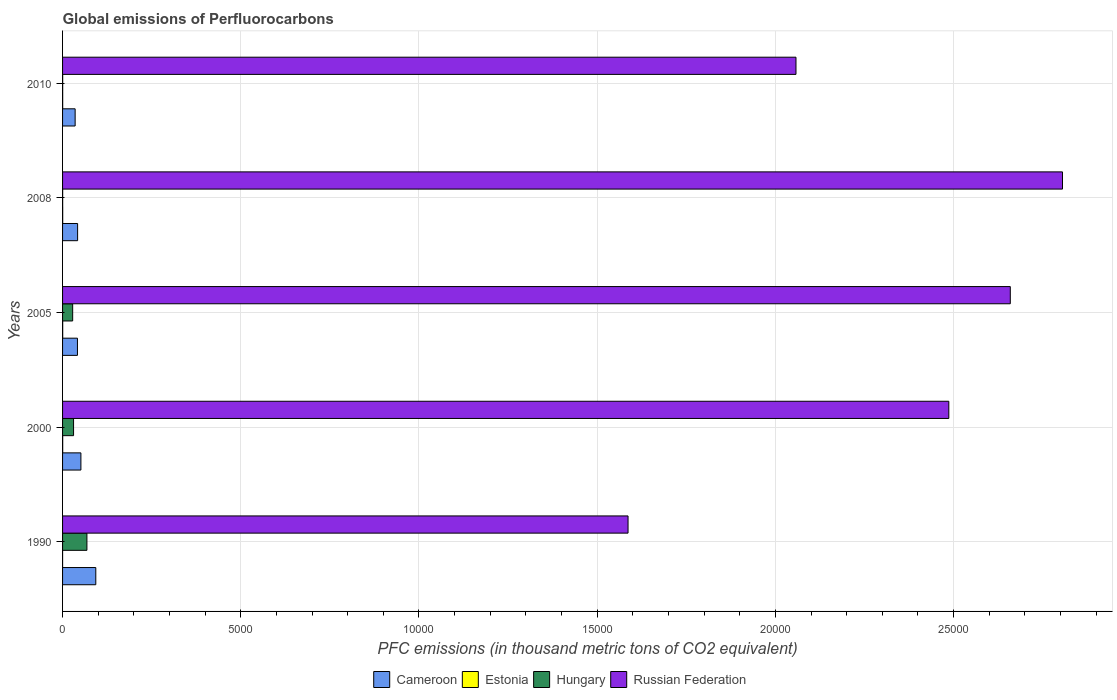How many bars are there on the 5th tick from the top?
Provide a succinct answer. 4. How many bars are there on the 4th tick from the bottom?
Offer a very short reply. 4. What is the label of the 1st group of bars from the top?
Your response must be concise. 2010. What is the global emissions of Perfluorocarbons in Russian Federation in 2010?
Offer a terse response. 2.06e+04. Across all years, what is the maximum global emissions of Perfluorocarbons in Russian Federation?
Offer a terse response. 2.81e+04. Across all years, what is the minimum global emissions of Perfluorocarbons in Russian Federation?
Give a very brief answer. 1.59e+04. In which year was the global emissions of Perfluorocarbons in Estonia maximum?
Provide a short and direct response. 2000. What is the total global emissions of Perfluorocarbons in Russian Federation in the graph?
Make the answer very short. 1.16e+05. What is the difference between the global emissions of Perfluorocarbons in Estonia in 2008 and that in 2010?
Provide a succinct answer. 0.4. What is the difference between the global emissions of Perfluorocarbons in Cameroon in 2010 and the global emissions of Perfluorocarbons in Hungary in 2000?
Provide a succinct answer. 44.5. What is the average global emissions of Perfluorocarbons in Russian Federation per year?
Provide a short and direct response. 2.32e+04. In the year 2000, what is the difference between the global emissions of Perfluorocarbons in Russian Federation and global emissions of Perfluorocarbons in Cameroon?
Your answer should be very brief. 2.44e+04. What is the ratio of the global emissions of Perfluorocarbons in Hungary in 2000 to that in 2005?
Ensure brevity in your answer.  1.09. Is the difference between the global emissions of Perfluorocarbons in Russian Federation in 1990 and 2000 greater than the difference between the global emissions of Perfluorocarbons in Cameroon in 1990 and 2000?
Provide a short and direct response. No. What is the difference between the highest and the second highest global emissions of Perfluorocarbons in Cameroon?
Your answer should be compact. 417.6. What is the difference between the highest and the lowest global emissions of Perfluorocarbons in Estonia?
Give a very brief answer. 3. Is the sum of the global emissions of Perfluorocarbons in Cameroon in 2000 and 2008 greater than the maximum global emissions of Perfluorocarbons in Estonia across all years?
Keep it short and to the point. Yes. Is it the case that in every year, the sum of the global emissions of Perfluorocarbons in Hungary and global emissions of Perfluorocarbons in Cameroon is greater than the sum of global emissions of Perfluorocarbons in Estonia and global emissions of Perfluorocarbons in Russian Federation?
Give a very brief answer. No. What does the 3rd bar from the top in 2010 represents?
Keep it short and to the point. Estonia. What does the 4th bar from the bottom in 2005 represents?
Give a very brief answer. Russian Federation. Are all the bars in the graph horizontal?
Make the answer very short. Yes. What is the title of the graph?
Your answer should be compact. Global emissions of Perfluorocarbons. Does "Albania" appear as one of the legend labels in the graph?
Ensure brevity in your answer.  No. What is the label or title of the X-axis?
Offer a terse response. PFC emissions (in thousand metric tons of CO2 equivalent). What is the label or title of the Y-axis?
Offer a very short reply. Years. What is the PFC emissions (in thousand metric tons of CO2 equivalent) of Cameroon in 1990?
Provide a short and direct response. 932.3. What is the PFC emissions (in thousand metric tons of CO2 equivalent) in Estonia in 1990?
Your response must be concise. 0.5. What is the PFC emissions (in thousand metric tons of CO2 equivalent) in Hungary in 1990?
Offer a very short reply. 683.3. What is the PFC emissions (in thousand metric tons of CO2 equivalent) in Russian Federation in 1990?
Provide a short and direct response. 1.59e+04. What is the PFC emissions (in thousand metric tons of CO2 equivalent) in Cameroon in 2000?
Provide a succinct answer. 514.7. What is the PFC emissions (in thousand metric tons of CO2 equivalent) in Hungary in 2000?
Give a very brief answer. 308.5. What is the PFC emissions (in thousand metric tons of CO2 equivalent) of Russian Federation in 2000?
Keep it short and to the point. 2.49e+04. What is the PFC emissions (in thousand metric tons of CO2 equivalent) in Cameroon in 2005?
Keep it short and to the point. 417.5. What is the PFC emissions (in thousand metric tons of CO2 equivalent) of Estonia in 2005?
Your answer should be compact. 3.4. What is the PFC emissions (in thousand metric tons of CO2 equivalent) of Hungary in 2005?
Provide a short and direct response. 283.7. What is the PFC emissions (in thousand metric tons of CO2 equivalent) in Russian Federation in 2005?
Your answer should be compact. 2.66e+04. What is the PFC emissions (in thousand metric tons of CO2 equivalent) in Cameroon in 2008?
Make the answer very short. 422.1. What is the PFC emissions (in thousand metric tons of CO2 equivalent) of Estonia in 2008?
Offer a very short reply. 3.4. What is the PFC emissions (in thousand metric tons of CO2 equivalent) in Russian Federation in 2008?
Give a very brief answer. 2.81e+04. What is the PFC emissions (in thousand metric tons of CO2 equivalent) in Cameroon in 2010?
Make the answer very short. 353. What is the PFC emissions (in thousand metric tons of CO2 equivalent) of Hungary in 2010?
Give a very brief answer. 3. What is the PFC emissions (in thousand metric tons of CO2 equivalent) of Russian Federation in 2010?
Ensure brevity in your answer.  2.06e+04. Across all years, what is the maximum PFC emissions (in thousand metric tons of CO2 equivalent) of Cameroon?
Ensure brevity in your answer.  932.3. Across all years, what is the maximum PFC emissions (in thousand metric tons of CO2 equivalent) of Hungary?
Your answer should be compact. 683.3. Across all years, what is the maximum PFC emissions (in thousand metric tons of CO2 equivalent) of Russian Federation?
Make the answer very short. 2.81e+04. Across all years, what is the minimum PFC emissions (in thousand metric tons of CO2 equivalent) of Cameroon?
Keep it short and to the point. 353. Across all years, what is the minimum PFC emissions (in thousand metric tons of CO2 equivalent) in Estonia?
Ensure brevity in your answer.  0.5. Across all years, what is the minimum PFC emissions (in thousand metric tons of CO2 equivalent) in Russian Federation?
Your answer should be compact. 1.59e+04. What is the total PFC emissions (in thousand metric tons of CO2 equivalent) in Cameroon in the graph?
Make the answer very short. 2639.6. What is the total PFC emissions (in thousand metric tons of CO2 equivalent) of Hungary in the graph?
Your response must be concise. 1281.2. What is the total PFC emissions (in thousand metric tons of CO2 equivalent) in Russian Federation in the graph?
Ensure brevity in your answer.  1.16e+05. What is the difference between the PFC emissions (in thousand metric tons of CO2 equivalent) of Cameroon in 1990 and that in 2000?
Offer a very short reply. 417.6. What is the difference between the PFC emissions (in thousand metric tons of CO2 equivalent) of Hungary in 1990 and that in 2000?
Your answer should be very brief. 374.8. What is the difference between the PFC emissions (in thousand metric tons of CO2 equivalent) in Russian Federation in 1990 and that in 2000?
Your answer should be very brief. -8999.9. What is the difference between the PFC emissions (in thousand metric tons of CO2 equivalent) of Cameroon in 1990 and that in 2005?
Give a very brief answer. 514.8. What is the difference between the PFC emissions (in thousand metric tons of CO2 equivalent) of Estonia in 1990 and that in 2005?
Ensure brevity in your answer.  -2.9. What is the difference between the PFC emissions (in thousand metric tons of CO2 equivalent) in Hungary in 1990 and that in 2005?
Give a very brief answer. 399.6. What is the difference between the PFC emissions (in thousand metric tons of CO2 equivalent) in Russian Federation in 1990 and that in 2005?
Ensure brevity in your answer.  -1.07e+04. What is the difference between the PFC emissions (in thousand metric tons of CO2 equivalent) in Cameroon in 1990 and that in 2008?
Ensure brevity in your answer.  510.2. What is the difference between the PFC emissions (in thousand metric tons of CO2 equivalent) in Hungary in 1990 and that in 2008?
Your answer should be very brief. 680.6. What is the difference between the PFC emissions (in thousand metric tons of CO2 equivalent) in Russian Federation in 1990 and that in 2008?
Ensure brevity in your answer.  -1.22e+04. What is the difference between the PFC emissions (in thousand metric tons of CO2 equivalent) in Cameroon in 1990 and that in 2010?
Offer a terse response. 579.3. What is the difference between the PFC emissions (in thousand metric tons of CO2 equivalent) in Hungary in 1990 and that in 2010?
Your response must be concise. 680.3. What is the difference between the PFC emissions (in thousand metric tons of CO2 equivalent) of Russian Federation in 1990 and that in 2010?
Provide a succinct answer. -4711.8. What is the difference between the PFC emissions (in thousand metric tons of CO2 equivalent) in Cameroon in 2000 and that in 2005?
Keep it short and to the point. 97.2. What is the difference between the PFC emissions (in thousand metric tons of CO2 equivalent) of Hungary in 2000 and that in 2005?
Your answer should be very brief. 24.8. What is the difference between the PFC emissions (in thousand metric tons of CO2 equivalent) of Russian Federation in 2000 and that in 2005?
Give a very brief answer. -1725.2. What is the difference between the PFC emissions (in thousand metric tons of CO2 equivalent) in Cameroon in 2000 and that in 2008?
Offer a very short reply. 92.6. What is the difference between the PFC emissions (in thousand metric tons of CO2 equivalent) of Estonia in 2000 and that in 2008?
Provide a succinct answer. 0.1. What is the difference between the PFC emissions (in thousand metric tons of CO2 equivalent) of Hungary in 2000 and that in 2008?
Keep it short and to the point. 305.8. What is the difference between the PFC emissions (in thousand metric tons of CO2 equivalent) of Russian Federation in 2000 and that in 2008?
Give a very brief answer. -3189.7. What is the difference between the PFC emissions (in thousand metric tons of CO2 equivalent) in Cameroon in 2000 and that in 2010?
Offer a terse response. 161.7. What is the difference between the PFC emissions (in thousand metric tons of CO2 equivalent) in Estonia in 2000 and that in 2010?
Keep it short and to the point. 0.5. What is the difference between the PFC emissions (in thousand metric tons of CO2 equivalent) in Hungary in 2000 and that in 2010?
Keep it short and to the point. 305.5. What is the difference between the PFC emissions (in thousand metric tons of CO2 equivalent) in Russian Federation in 2000 and that in 2010?
Your answer should be compact. 4288.1. What is the difference between the PFC emissions (in thousand metric tons of CO2 equivalent) of Estonia in 2005 and that in 2008?
Provide a succinct answer. 0. What is the difference between the PFC emissions (in thousand metric tons of CO2 equivalent) of Hungary in 2005 and that in 2008?
Provide a succinct answer. 281. What is the difference between the PFC emissions (in thousand metric tons of CO2 equivalent) of Russian Federation in 2005 and that in 2008?
Ensure brevity in your answer.  -1464.5. What is the difference between the PFC emissions (in thousand metric tons of CO2 equivalent) of Cameroon in 2005 and that in 2010?
Give a very brief answer. 64.5. What is the difference between the PFC emissions (in thousand metric tons of CO2 equivalent) of Estonia in 2005 and that in 2010?
Your answer should be compact. 0.4. What is the difference between the PFC emissions (in thousand metric tons of CO2 equivalent) in Hungary in 2005 and that in 2010?
Keep it short and to the point. 280.7. What is the difference between the PFC emissions (in thousand metric tons of CO2 equivalent) of Russian Federation in 2005 and that in 2010?
Provide a short and direct response. 6013.3. What is the difference between the PFC emissions (in thousand metric tons of CO2 equivalent) of Cameroon in 2008 and that in 2010?
Your response must be concise. 69.1. What is the difference between the PFC emissions (in thousand metric tons of CO2 equivalent) in Estonia in 2008 and that in 2010?
Your answer should be very brief. 0.4. What is the difference between the PFC emissions (in thousand metric tons of CO2 equivalent) in Russian Federation in 2008 and that in 2010?
Your answer should be very brief. 7477.8. What is the difference between the PFC emissions (in thousand metric tons of CO2 equivalent) in Cameroon in 1990 and the PFC emissions (in thousand metric tons of CO2 equivalent) in Estonia in 2000?
Offer a terse response. 928.8. What is the difference between the PFC emissions (in thousand metric tons of CO2 equivalent) in Cameroon in 1990 and the PFC emissions (in thousand metric tons of CO2 equivalent) in Hungary in 2000?
Make the answer very short. 623.8. What is the difference between the PFC emissions (in thousand metric tons of CO2 equivalent) of Cameroon in 1990 and the PFC emissions (in thousand metric tons of CO2 equivalent) of Russian Federation in 2000?
Your answer should be very brief. -2.39e+04. What is the difference between the PFC emissions (in thousand metric tons of CO2 equivalent) of Estonia in 1990 and the PFC emissions (in thousand metric tons of CO2 equivalent) of Hungary in 2000?
Provide a short and direct response. -308. What is the difference between the PFC emissions (in thousand metric tons of CO2 equivalent) in Estonia in 1990 and the PFC emissions (in thousand metric tons of CO2 equivalent) in Russian Federation in 2000?
Provide a short and direct response. -2.49e+04. What is the difference between the PFC emissions (in thousand metric tons of CO2 equivalent) of Hungary in 1990 and the PFC emissions (in thousand metric tons of CO2 equivalent) of Russian Federation in 2000?
Your answer should be compact. -2.42e+04. What is the difference between the PFC emissions (in thousand metric tons of CO2 equivalent) in Cameroon in 1990 and the PFC emissions (in thousand metric tons of CO2 equivalent) in Estonia in 2005?
Make the answer very short. 928.9. What is the difference between the PFC emissions (in thousand metric tons of CO2 equivalent) in Cameroon in 1990 and the PFC emissions (in thousand metric tons of CO2 equivalent) in Hungary in 2005?
Keep it short and to the point. 648.6. What is the difference between the PFC emissions (in thousand metric tons of CO2 equivalent) in Cameroon in 1990 and the PFC emissions (in thousand metric tons of CO2 equivalent) in Russian Federation in 2005?
Make the answer very short. -2.57e+04. What is the difference between the PFC emissions (in thousand metric tons of CO2 equivalent) of Estonia in 1990 and the PFC emissions (in thousand metric tons of CO2 equivalent) of Hungary in 2005?
Provide a short and direct response. -283.2. What is the difference between the PFC emissions (in thousand metric tons of CO2 equivalent) in Estonia in 1990 and the PFC emissions (in thousand metric tons of CO2 equivalent) in Russian Federation in 2005?
Ensure brevity in your answer.  -2.66e+04. What is the difference between the PFC emissions (in thousand metric tons of CO2 equivalent) of Hungary in 1990 and the PFC emissions (in thousand metric tons of CO2 equivalent) of Russian Federation in 2005?
Provide a short and direct response. -2.59e+04. What is the difference between the PFC emissions (in thousand metric tons of CO2 equivalent) in Cameroon in 1990 and the PFC emissions (in thousand metric tons of CO2 equivalent) in Estonia in 2008?
Ensure brevity in your answer.  928.9. What is the difference between the PFC emissions (in thousand metric tons of CO2 equivalent) in Cameroon in 1990 and the PFC emissions (in thousand metric tons of CO2 equivalent) in Hungary in 2008?
Ensure brevity in your answer.  929.6. What is the difference between the PFC emissions (in thousand metric tons of CO2 equivalent) in Cameroon in 1990 and the PFC emissions (in thousand metric tons of CO2 equivalent) in Russian Federation in 2008?
Your answer should be compact. -2.71e+04. What is the difference between the PFC emissions (in thousand metric tons of CO2 equivalent) of Estonia in 1990 and the PFC emissions (in thousand metric tons of CO2 equivalent) of Russian Federation in 2008?
Your answer should be very brief. -2.81e+04. What is the difference between the PFC emissions (in thousand metric tons of CO2 equivalent) of Hungary in 1990 and the PFC emissions (in thousand metric tons of CO2 equivalent) of Russian Federation in 2008?
Give a very brief answer. -2.74e+04. What is the difference between the PFC emissions (in thousand metric tons of CO2 equivalent) of Cameroon in 1990 and the PFC emissions (in thousand metric tons of CO2 equivalent) of Estonia in 2010?
Keep it short and to the point. 929.3. What is the difference between the PFC emissions (in thousand metric tons of CO2 equivalent) of Cameroon in 1990 and the PFC emissions (in thousand metric tons of CO2 equivalent) of Hungary in 2010?
Give a very brief answer. 929.3. What is the difference between the PFC emissions (in thousand metric tons of CO2 equivalent) in Cameroon in 1990 and the PFC emissions (in thousand metric tons of CO2 equivalent) in Russian Federation in 2010?
Your answer should be very brief. -1.96e+04. What is the difference between the PFC emissions (in thousand metric tons of CO2 equivalent) in Estonia in 1990 and the PFC emissions (in thousand metric tons of CO2 equivalent) in Hungary in 2010?
Make the answer very short. -2.5. What is the difference between the PFC emissions (in thousand metric tons of CO2 equivalent) in Estonia in 1990 and the PFC emissions (in thousand metric tons of CO2 equivalent) in Russian Federation in 2010?
Offer a terse response. -2.06e+04. What is the difference between the PFC emissions (in thousand metric tons of CO2 equivalent) in Hungary in 1990 and the PFC emissions (in thousand metric tons of CO2 equivalent) in Russian Federation in 2010?
Make the answer very short. -1.99e+04. What is the difference between the PFC emissions (in thousand metric tons of CO2 equivalent) in Cameroon in 2000 and the PFC emissions (in thousand metric tons of CO2 equivalent) in Estonia in 2005?
Your answer should be compact. 511.3. What is the difference between the PFC emissions (in thousand metric tons of CO2 equivalent) of Cameroon in 2000 and the PFC emissions (in thousand metric tons of CO2 equivalent) of Hungary in 2005?
Offer a terse response. 231. What is the difference between the PFC emissions (in thousand metric tons of CO2 equivalent) in Cameroon in 2000 and the PFC emissions (in thousand metric tons of CO2 equivalent) in Russian Federation in 2005?
Offer a terse response. -2.61e+04. What is the difference between the PFC emissions (in thousand metric tons of CO2 equivalent) in Estonia in 2000 and the PFC emissions (in thousand metric tons of CO2 equivalent) in Hungary in 2005?
Provide a succinct answer. -280.2. What is the difference between the PFC emissions (in thousand metric tons of CO2 equivalent) of Estonia in 2000 and the PFC emissions (in thousand metric tons of CO2 equivalent) of Russian Federation in 2005?
Make the answer very short. -2.66e+04. What is the difference between the PFC emissions (in thousand metric tons of CO2 equivalent) of Hungary in 2000 and the PFC emissions (in thousand metric tons of CO2 equivalent) of Russian Federation in 2005?
Offer a terse response. -2.63e+04. What is the difference between the PFC emissions (in thousand metric tons of CO2 equivalent) in Cameroon in 2000 and the PFC emissions (in thousand metric tons of CO2 equivalent) in Estonia in 2008?
Make the answer very short. 511.3. What is the difference between the PFC emissions (in thousand metric tons of CO2 equivalent) of Cameroon in 2000 and the PFC emissions (in thousand metric tons of CO2 equivalent) of Hungary in 2008?
Your response must be concise. 512. What is the difference between the PFC emissions (in thousand metric tons of CO2 equivalent) in Cameroon in 2000 and the PFC emissions (in thousand metric tons of CO2 equivalent) in Russian Federation in 2008?
Provide a succinct answer. -2.75e+04. What is the difference between the PFC emissions (in thousand metric tons of CO2 equivalent) of Estonia in 2000 and the PFC emissions (in thousand metric tons of CO2 equivalent) of Hungary in 2008?
Offer a terse response. 0.8. What is the difference between the PFC emissions (in thousand metric tons of CO2 equivalent) in Estonia in 2000 and the PFC emissions (in thousand metric tons of CO2 equivalent) in Russian Federation in 2008?
Your answer should be compact. -2.81e+04. What is the difference between the PFC emissions (in thousand metric tons of CO2 equivalent) of Hungary in 2000 and the PFC emissions (in thousand metric tons of CO2 equivalent) of Russian Federation in 2008?
Your response must be concise. -2.77e+04. What is the difference between the PFC emissions (in thousand metric tons of CO2 equivalent) of Cameroon in 2000 and the PFC emissions (in thousand metric tons of CO2 equivalent) of Estonia in 2010?
Provide a succinct answer. 511.7. What is the difference between the PFC emissions (in thousand metric tons of CO2 equivalent) of Cameroon in 2000 and the PFC emissions (in thousand metric tons of CO2 equivalent) of Hungary in 2010?
Give a very brief answer. 511.7. What is the difference between the PFC emissions (in thousand metric tons of CO2 equivalent) in Cameroon in 2000 and the PFC emissions (in thousand metric tons of CO2 equivalent) in Russian Federation in 2010?
Your response must be concise. -2.01e+04. What is the difference between the PFC emissions (in thousand metric tons of CO2 equivalent) in Estonia in 2000 and the PFC emissions (in thousand metric tons of CO2 equivalent) in Russian Federation in 2010?
Your response must be concise. -2.06e+04. What is the difference between the PFC emissions (in thousand metric tons of CO2 equivalent) of Hungary in 2000 and the PFC emissions (in thousand metric tons of CO2 equivalent) of Russian Federation in 2010?
Your answer should be very brief. -2.03e+04. What is the difference between the PFC emissions (in thousand metric tons of CO2 equivalent) in Cameroon in 2005 and the PFC emissions (in thousand metric tons of CO2 equivalent) in Estonia in 2008?
Your response must be concise. 414.1. What is the difference between the PFC emissions (in thousand metric tons of CO2 equivalent) in Cameroon in 2005 and the PFC emissions (in thousand metric tons of CO2 equivalent) in Hungary in 2008?
Ensure brevity in your answer.  414.8. What is the difference between the PFC emissions (in thousand metric tons of CO2 equivalent) in Cameroon in 2005 and the PFC emissions (in thousand metric tons of CO2 equivalent) in Russian Federation in 2008?
Your response must be concise. -2.76e+04. What is the difference between the PFC emissions (in thousand metric tons of CO2 equivalent) in Estonia in 2005 and the PFC emissions (in thousand metric tons of CO2 equivalent) in Hungary in 2008?
Provide a short and direct response. 0.7. What is the difference between the PFC emissions (in thousand metric tons of CO2 equivalent) in Estonia in 2005 and the PFC emissions (in thousand metric tons of CO2 equivalent) in Russian Federation in 2008?
Your answer should be compact. -2.81e+04. What is the difference between the PFC emissions (in thousand metric tons of CO2 equivalent) of Hungary in 2005 and the PFC emissions (in thousand metric tons of CO2 equivalent) of Russian Federation in 2008?
Provide a succinct answer. -2.78e+04. What is the difference between the PFC emissions (in thousand metric tons of CO2 equivalent) in Cameroon in 2005 and the PFC emissions (in thousand metric tons of CO2 equivalent) in Estonia in 2010?
Keep it short and to the point. 414.5. What is the difference between the PFC emissions (in thousand metric tons of CO2 equivalent) of Cameroon in 2005 and the PFC emissions (in thousand metric tons of CO2 equivalent) of Hungary in 2010?
Your response must be concise. 414.5. What is the difference between the PFC emissions (in thousand metric tons of CO2 equivalent) in Cameroon in 2005 and the PFC emissions (in thousand metric tons of CO2 equivalent) in Russian Federation in 2010?
Your response must be concise. -2.02e+04. What is the difference between the PFC emissions (in thousand metric tons of CO2 equivalent) of Estonia in 2005 and the PFC emissions (in thousand metric tons of CO2 equivalent) of Russian Federation in 2010?
Offer a very short reply. -2.06e+04. What is the difference between the PFC emissions (in thousand metric tons of CO2 equivalent) of Hungary in 2005 and the PFC emissions (in thousand metric tons of CO2 equivalent) of Russian Federation in 2010?
Your answer should be compact. -2.03e+04. What is the difference between the PFC emissions (in thousand metric tons of CO2 equivalent) in Cameroon in 2008 and the PFC emissions (in thousand metric tons of CO2 equivalent) in Estonia in 2010?
Offer a very short reply. 419.1. What is the difference between the PFC emissions (in thousand metric tons of CO2 equivalent) in Cameroon in 2008 and the PFC emissions (in thousand metric tons of CO2 equivalent) in Hungary in 2010?
Offer a very short reply. 419.1. What is the difference between the PFC emissions (in thousand metric tons of CO2 equivalent) in Cameroon in 2008 and the PFC emissions (in thousand metric tons of CO2 equivalent) in Russian Federation in 2010?
Your response must be concise. -2.02e+04. What is the difference between the PFC emissions (in thousand metric tons of CO2 equivalent) in Estonia in 2008 and the PFC emissions (in thousand metric tons of CO2 equivalent) in Russian Federation in 2010?
Give a very brief answer. -2.06e+04. What is the difference between the PFC emissions (in thousand metric tons of CO2 equivalent) of Hungary in 2008 and the PFC emissions (in thousand metric tons of CO2 equivalent) of Russian Federation in 2010?
Offer a very short reply. -2.06e+04. What is the average PFC emissions (in thousand metric tons of CO2 equivalent) in Cameroon per year?
Provide a succinct answer. 527.92. What is the average PFC emissions (in thousand metric tons of CO2 equivalent) in Estonia per year?
Give a very brief answer. 2.76. What is the average PFC emissions (in thousand metric tons of CO2 equivalent) in Hungary per year?
Ensure brevity in your answer.  256.24. What is the average PFC emissions (in thousand metric tons of CO2 equivalent) in Russian Federation per year?
Your response must be concise. 2.32e+04. In the year 1990, what is the difference between the PFC emissions (in thousand metric tons of CO2 equivalent) of Cameroon and PFC emissions (in thousand metric tons of CO2 equivalent) of Estonia?
Your answer should be compact. 931.8. In the year 1990, what is the difference between the PFC emissions (in thousand metric tons of CO2 equivalent) in Cameroon and PFC emissions (in thousand metric tons of CO2 equivalent) in Hungary?
Give a very brief answer. 249. In the year 1990, what is the difference between the PFC emissions (in thousand metric tons of CO2 equivalent) in Cameroon and PFC emissions (in thousand metric tons of CO2 equivalent) in Russian Federation?
Give a very brief answer. -1.49e+04. In the year 1990, what is the difference between the PFC emissions (in thousand metric tons of CO2 equivalent) in Estonia and PFC emissions (in thousand metric tons of CO2 equivalent) in Hungary?
Your answer should be very brief. -682.8. In the year 1990, what is the difference between the PFC emissions (in thousand metric tons of CO2 equivalent) of Estonia and PFC emissions (in thousand metric tons of CO2 equivalent) of Russian Federation?
Provide a short and direct response. -1.59e+04. In the year 1990, what is the difference between the PFC emissions (in thousand metric tons of CO2 equivalent) in Hungary and PFC emissions (in thousand metric tons of CO2 equivalent) in Russian Federation?
Provide a succinct answer. -1.52e+04. In the year 2000, what is the difference between the PFC emissions (in thousand metric tons of CO2 equivalent) of Cameroon and PFC emissions (in thousand metric tons of CO2 equivalent) of Estonia?
Ensure brevity in your answer.  511.2. In the year 2000, what is the difference between the PFC emissions (in thousand metric tons of CO2 equivalent) of Cameroon and PFC emissions (in thousand metric tons of CO2 equivalent) of Hungary?
Give a very brief answer. 206.2. In the year 2000, what is the difference between the PFC emissions (in thousand metric tons of CO2 equivalent) in Cameroon and PFC emissions (in thousand metric tons of CO2 equivalent) in Russian Federation?
Your answer should be compact. -2.44e+04. In the year 2000, what is the difference between the PFC emissions (in thousand metric tons of CO2 equivalent) in Estonia and PFC emissions (in thousand metric tons of CO2 equivalent) in Hungary?
Your answer should be compact. -305. In the year 2000, what is the difference between the PFC emissions (in thousand metric tons of CO2 equivalent) of Estonia and PFC emissions (in thousand metric tons of CO2 equivalent) of Russian Federation?
Your response must be concise. -2.49e+04. In the year 2000, what is the difference between the PFC emissions (in thousand metric tons of CO2 equivalent) in Hungary and PFC emissions (in thousand metric tons of CO2 equivalent) in Russian Federation?
Provide a short and direct response. -2.46e+04. In the year 2005, what is the difference between the PFC emissions (in thousand metric tons of CO2 equivalent) of Cameroon and PFC emissions (in thousand metric tons of CO2 equivalent) of Estonia?
Ensure brevity in your answer.  414.1. In the year 2005, what is the difference between the PFC emissions (in thousand metric tons of CO2 equivalent) in Cameroon and PFC emissions (in thousand metric tons of CO2 equivalent) in Hungary?
Give a very brief answer. 133.8. In the year 2005, what is the difference between the PFC emissions (in thousand metric tons of CO2 equivalent) of Cameroon and PFC emissions (in thousand metric tons of CO2 equivalent) of Russian Federation?
Provide a succinct answer. -2.62e+04. In the year 2005, what is the difference between the PFC emissions (in thousand metric tons of CO2 equivalent) in Estonia and PFC emissions (in thousand metric tons of CO2 equivalent) in Hungary?
Offer a very short reply. -280.3. In the year 2005, what is the difference between the PFC emissions (in thousand metric tons of CO2 equivalent) of Estonia and PFC emissions (in thousand metric tons of CO2 equivalent) of Russian Federation?
Keep it short and to the point. -2.66e+04. In the year 2005, what is the difference between the PFC emissions (in thousand metric tons of CO2 equivalent) of Hungary and PFC emissions (in thousand metric tons of CO2 equivalent) of Russian Federation?
Offer a terse response. -2.63e+04. In the year 2008, what is the difference between the PFC emissions (in thousand metric tons of CO2 equivalent) of Cameroon and PFC emissions (in thousand metric tons of CO2 equivalent) of Estonia?
Your response must be concise. 418.7. In the year 2008, what is the difference between the PFC emissions (in thousand metric tons of CO2 equivalent) of Cameroon and PFC emissions (in thousand metric tons of CO2 equivalent) of Hungary?
Ensure brevity in your answer.  419.4. In the year 2008, what is the difference between the PFC emissions (in thousand metric tons of CO2 equivalent) in Cameroon and PFC emissions (in thousand metric tons of CO2 equivalent) in Russian Federation?
Your answer should be compact. -2.76e+04. In the year 2008, what is the difference between the PFC emissions (in thousand metric tons of CO2 equivalent) in Estonia and PFC emissions (in thousand metric tons of CO2 equivalent) in Hungary?
Offer a terse response. 0.7. In the year 2008, what is the difference between the PFC emissions (in thousand metric tons of CO2 equivalent) in Estonia and PFC emissions (in thousand metric tons of CO2 equivalent) in Russian Federation?
Your answer should be very brief. -2.81e+04. In the year 2008, what is the difference between the PFC emissions (in thousand metric tons of CO2 equivalent) in Hungary and PFC emissions (in thousand metric tons of CO2 equivalent) in Russian Federation?
Your answer should be compact. -2.81e+04. In the year 2010, what is the difference between the PFC emissions (in thousand metric tons of CO2 equivalent) of Cameroon and PFC emissions (in thousand metric tons of CO2 equivalent) of Estonia?
Your response must be concise. 350. In the year 2010, what is the difference between the PFC emissions (in thousand metric tons of CO2 equivalent) in Cameroon and PFC emissions (in thousand metric tons of CO2 equivalent) in Hungary?
Make the answer very short. 350. In the year 2010, what is the difference between the PFC emissions (in thousand metric tons of CO2 equivalent) in Cameroon and PFC emissions (in thousand metric tons of CO2 equivalent) in Russian Federation?
Make the answer very short. -2.02e+04. In the year 2010, what is the difference between the PFC emissions (in thousand metric tons of CO2 equivalent) of Estonia and PFC emissions (in thousand metric tons of CO2 equivalent) of Russian Federation?
Ensure brevity in your answer.  -2.06e+04. In the year 2010, what is the difference between the PFC emissions (in thousand metric tons of CO2 equivalent) in Hungary and PFC emissions (in thousand metric tons of CO2 equivalent) in Russian Federation?
Make the answer very short. -2.06e+04. What is the ratio of the PFC emissions (in thousand metric tons of CO2 equivalent) of Cameroon in 1990 to that in 2000?
Provide a short and direct response. 1.81. What is the ratio of the PFC emissions (in thousand metric tons of CO2 equivalent) of Estonia in 1990 to that in 2000?
Your answer should be very brief. 0.14. What is the ratio of the PFC emissions (in thousand metric tons of CO2 equivalent) of Hungary in 1990 to that in 2000?
Your answer should be very brief. 2.21. What is the ratio of the PFC emissions (in thousand metric tons of CO2 equivalent) in Russian Federation in 1990 to that in 2000?
Provide a succinct answer. 0.64. What is the ratio of the PFC emissions (in thousand metric tons of CO2 equivalent) in Cameroon in 1990 to that in 2005?
Your answer should be compact. 2.23. What is the ratio of the PFC emissions (in thousand metric tons of CO2 equivalent) of Estonia in 1990 to that in 2005?
Offer a terse response. 0.15. What is the ratio of the PFC emissions (in thousand metric tons of CO2 equivalent) in Hungary in 1990 to that in 2005?
Keep it short and to the point. 2.41. What is the ratio of the PFC emissions (in thousand metric tons of CO2 equivalent) in Russian Federation in 1990 to that in 2005?
Your answer should be compact. 0.6. What is the ratio of the PFC emissions (in thousand metric tons of CO2 equivalent) of Cameroon in 1990 to that in 2008?
Your answer should be compact. 2.21. What is the ratio of the PFC emissions (in thousand metric tons of CO2 equivalent) of Estonia in 1990 to that in 2008?
Ensure brevity in your answer.  0.15. What is the ratio of the PFC emissions (in thousand metric tons of CO2 equivalent) of Hungary in 1990 to that in 2008?
Your response must be concise. 253.07. What is the ratio of the PFC emissions (in thousand metric tons of CO2 equivalent) in Russian Federation in 1990 to that in 2008?
Offer a terse response. 0.57. What is the ratio of the PFC emissions (in thousand metric tons of CO2 equivalent) of Cameroon in 1990 to that in 2010?
Your answer should be very brief. 2.64. What is the ratio of the PFC emissions (in thousand metric tons of CO2 equivalent) in Estonia in 1990 to that in 2010?
Your answer should be very brief. 0.17. What is the ratio of the PFC emissions (in thousand metric tons of CO2 equivalent) of Hungary in 1990 to that in 2010?
Offer a terse response. 227.77. What is the ratio of the PFC emissions (in thousand metric tons of CO2 equivalent) of Russian Federation in 1990 to that in 2010?
Keep it short and to the point. 0.77. What is the ratio of the PFC emissions (in thousand metric tons of CO2 equivalent) of Cameroon in 2000 to that in 2005?
Provide a short and direct response. 1.23. What is the ratio of the PFC emissions (in thousand metric tons of CO2 equivalent) in Estonia in 2000 to that in 2005?
Give a very brief answer. 1.03. What is the ratio of the PFC emissions (in thousand metric tons of CO2 equivalent) in Hungary in 2000 to that in 2005?
Make the answer very short. 1.09. What is the ratio of the PFC emissions (in thousand metric tons of CO2 equivalent) of Russian Federation in 2000 to that in 2005?
Provide a succinct answer. 0.94. What is the ratio of the PFC emissions (in thousand metric tons of CO2 equivalent) of Cameroon in 2000 to that in 2008?
Provide a short and direct response. 1.22. What is the ratio of the PFC emissions (in thousand metric tons of CO2 equivalent) of Estonia in 2000 to that in 2008?
Keep it short and to the point. 1.03. What is the ratio of the PFC emissions (in thousand metric tons of CO2 equivalent) in Hungary in 2000 to that in 2008?
Provide a short and direct response. 114.26. What is the ratio of the PFC emissions (in thousand metric tons of CO2 equivalent) in Russian Federation in 2000 to that in 2008?
Make the answer very short. 0.89. What is the ratio of the PFC emissions (in thousand metric tons of CO2 equivalent) of Cameroon in 2000 to that in 2010?
Your answer should be compact. 1.46. What is the ratio of the PFC emissions (in thousand metric tons of CO2 equivalent) of Estonia in 2000 to that in 2010?
Offer a very short reply. 1.17. What is the ratio of the PFC emissions (in thousand metric tons of CO2 equivalent) of Hungary in 2000 to that in 2010?
Give a very brief answer. 102.83. What is the ratio of the PFC emissions (in thousand metric tons of CO2 equivalent) in Russian Federation in 2000 to that in 2010?
Give a very brief answer. 1.21. What is the ratio of the PFC emissions (in thousand metric tons of CO2 equivalent) of Estonia in 2005 to that in 2008?
Offer a terse response. 1. What is the ratio of the PFC emissions (in thousand metric tons of CO2 equivalent) of Hungary in 2005 to that in 2008?
Provide a succinct answer. 105.07. What is the ratio of the PFC emissions (in thousand metric tons of CO2 equivalent) of Russian Federation in 2005 to that in 2008?
Provide a short and direct response. 0.95. What is the ratio of the PFC emissions (in thousand metric tons of CO2 equivalent) of Cameroon in 2005 to that in 2010?
Provide a succinct answer. 1.18. What is the ratio of the PFC emissions (in thousand metric tons of CO2 equivalent) in Estonia in 2005 to that in 2010?
Provide a short and direct response. 1.13. What is the ratio of the PFC emissions (in thousand metric tons of CO2 equivalent) in Hungary in 2005 to that in 2010?
Provide a short and direct response. 94.57. What is the ratio of the PFC emissions (in thousand metric tons of CO2 equivalent) in Russian Federation in 2005 to that in 2010?
Make the answer very short. 1.29. What is the ratio of the PFC emissions (in thousand metric tons of CO2 equivalent) in Cameroon in 2008 to that in 2010?
Make the answer very short. 1.2. What is the ratio of the PFC emissions (in thousand metric tons of CO2 equivalent) of Estonia in 2008 to that in 2010?
Ensure brevity in your answer.  1.13. What is the ratio of the PFC emissions (in thousand metric tons of CO2 equivalent) of Hungary in 2008 to that in 2010?
Make the answer very short. 0.9. What is the ratio of the PFC emissions (in thousand metric tons of CO2 equivalent) of Russian Federation in 2008 to that in 2010?
Provide a succinct answer. 1.36. What is the difference between the highest and the second highest PFC emissions (in thousand metric tons of CO2 equivalent) of Cameroon?
Provide a short and direct response. 417.6. What is the difference between the highest and the second highest PFC emissions (in thousand metric tons of CO2 equivalent) of Hungary?
Offer a very short reply. 374.8. What is the difference between the highest and the second highest PFC emissions (in thousand metric tons of CO2 equivalent) of Russian Federation?
Provide a succinct answer. 1464.5. What is the difference between the highest and the lowest PFC emissions (in thousand metric tons of CO2 equivalent) of Cameroon?
Keep it short and to the point. 579.3. What is the difference between the highest and the lowest PFC emissions (in thousand metric tons of CO2 equivalent) of Estonia?
Your response must be concise. 3. What is the difference between the highest and the lowest PFC emissions (in thousand metric tons of CO2 equivalent) in Hungary?
Give a very brief answer. 680.6. What is the difference between the highest and the lowest PFC emissions (in thousand metric tons of CO2 equivalent) of Russian Federation?
Offer a terse response. 1.22e+04. 